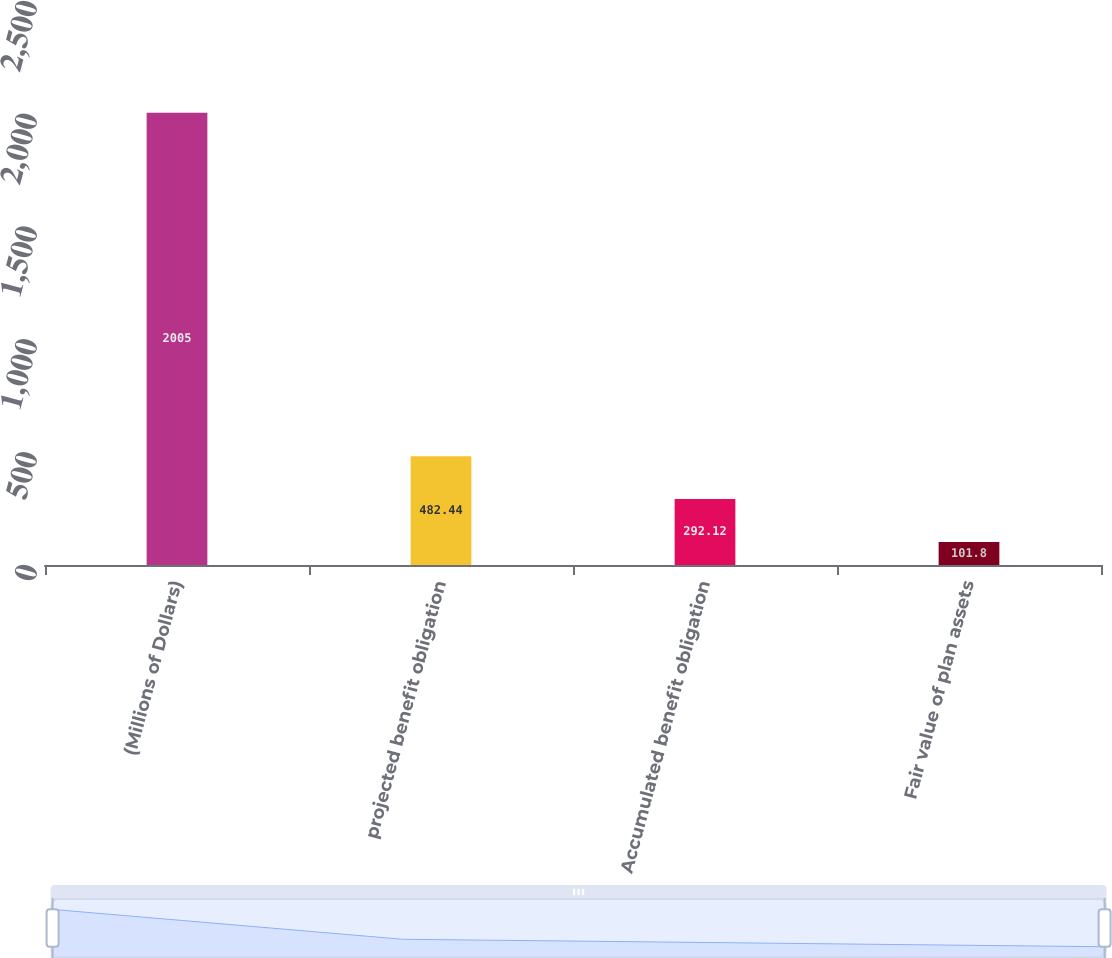<chart> <loc_0><loc_0><loc_500><loc_500><bar_chart><fcel>(Millions of Dollars)<fcel>projected benefit obligation<fcel>Accumulated benefit obligation<fcel>Fair value of plan assets<nl><fcel>2005<fcel>482.44<fcel>292.12<fcel>101.8<nl></chart> 